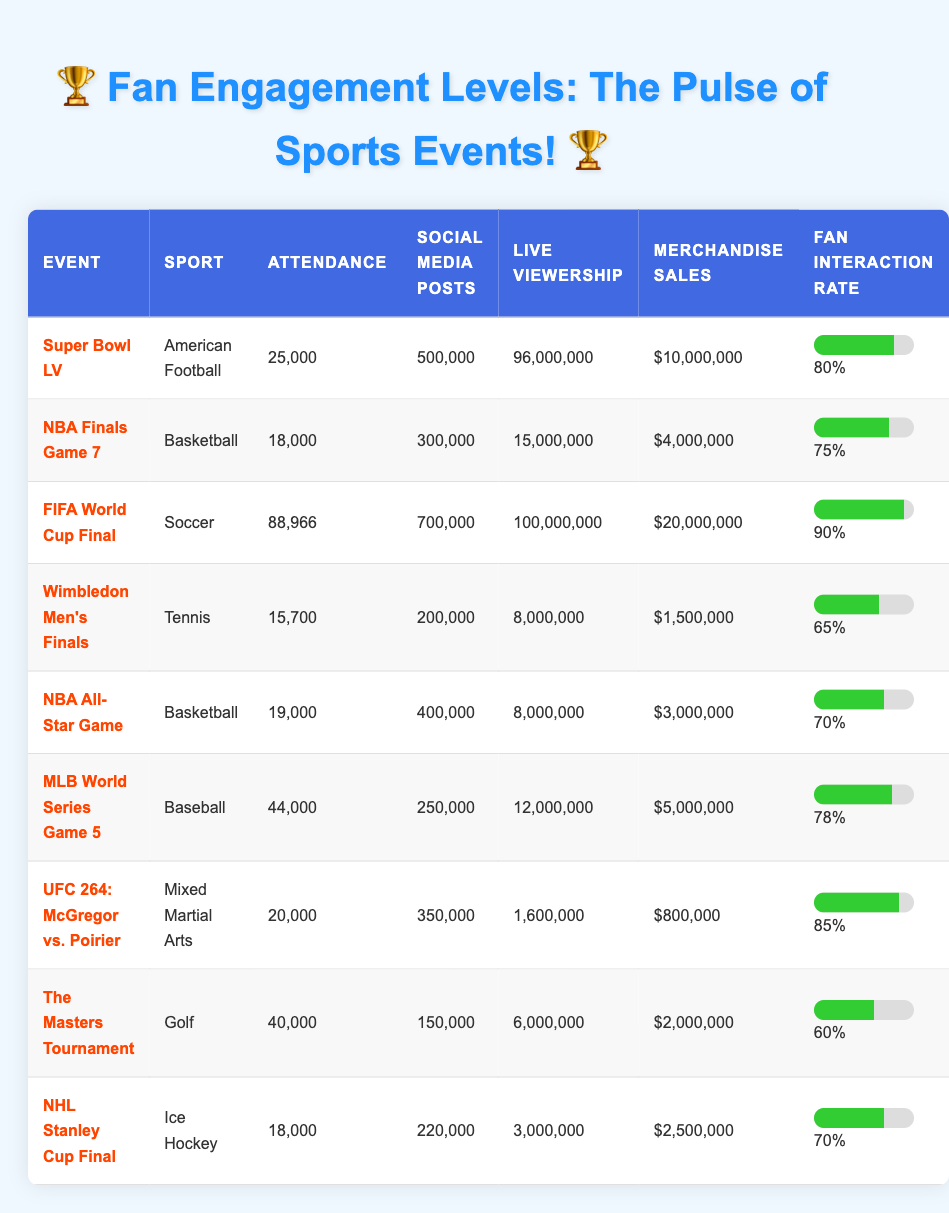What is the attendance for the FIFA World Cup Final? The table shows that the attendance for the FIFA World Cup Final is 88,966.
Answer: 88,966 What is the total merchandise sales for the Super Bowl LV and FIFA World Cup Final? The merchandise sales for the Super Bowl LV is $10,000,000, and for the FIFA World Cup Final, it is $20,000,000. Adding these two amounts together yields $10,000,000 + $20,000,000 = $30,000,000.
Answer: $30,000,000 Is the fan interaction rate for the NBA All-Star Game greater than 70%? The fan interaction rate for the NBA All-Star Game is 70%, which is not greater than 70%. Thus, the answer is no.
Answer: No What sport had the highest live viewership, and what was that number? The FIFA World Cup Final had the highest live viewership at 100,000,000.
Answer: Soccer; 100,000,000 What is the average attendance for all the events listed in the table? To calculate the average attendance, first sum the attendance values: 25,000 + 18,000 + 88,966 + 15,700 + 19,000 + 44,000 + 20,000 + 40,000 + 18,000 =  298,666. Then divide by the number of events (9): 298,666 / 9 = 33,185.11. Rounding to the nearest whole number gives an average attendance of 33,185.
Answer: 33,185 How many social media posts were made for the Wimbledon Men's Finals? The table indicates that there were 200,000 social media posts made for the Wimbledon Men's Finals.
Answer: 200,000 Did the UFC 264 event have more attendance than the MLB World Series Game 5? The UFC 264 event had an attendance of 20,000, while the MLB World Series Game 5 had 44,000. Since 20,000 is less than 44,000, the answer is no.
Answer: No What sport has the lowest fan interaction rate among the listed events? Reviewing the fan interaction rates, Wimbledon Men's Finals has the lowest rate at 65%.
Answer: Tennis; 65% 